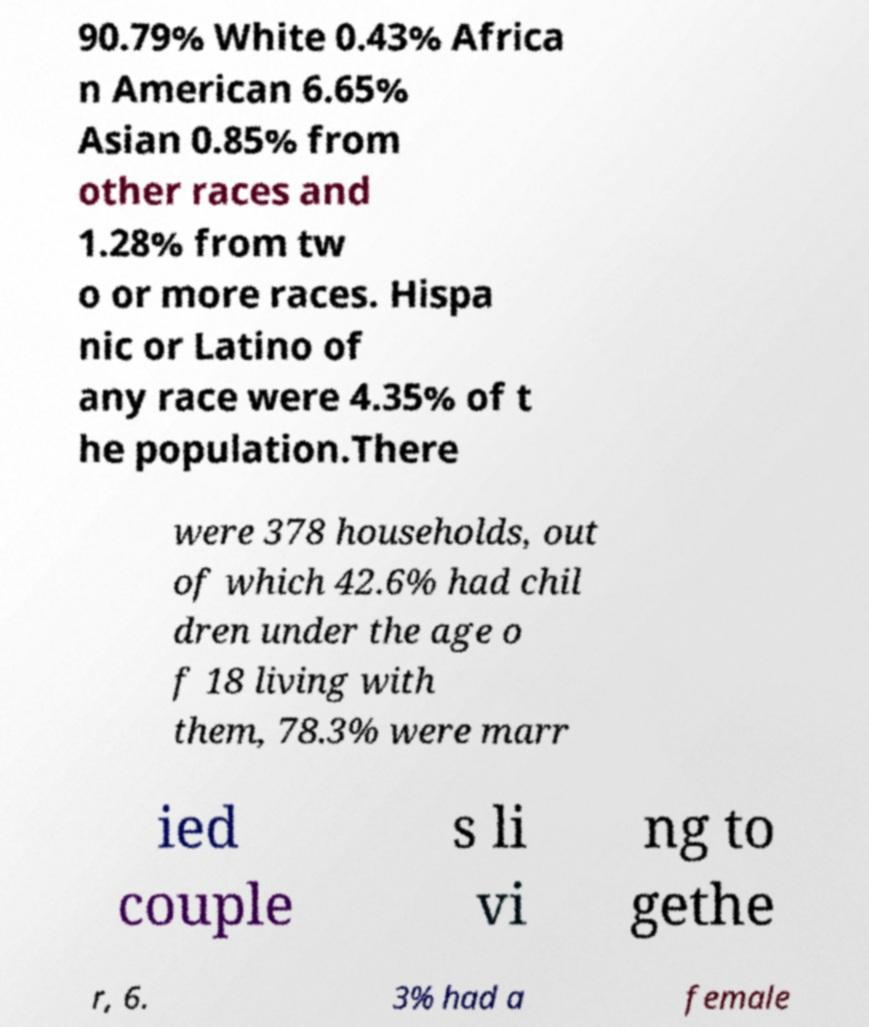Please identify and transcribe the text found in this image. 90.79% White 0.43% Africa n American 6.65% Asian 0.85% from other races and 1.28% from tw o or more races. Hispa nic or Latino of any race were 4.35% of t he population.There were 378 households, out of which 42.6% had chil dren under the age o f 18 living with them, 78.3% were marr ied couple s li vi ng to gethe r, 6. 3% had a female 